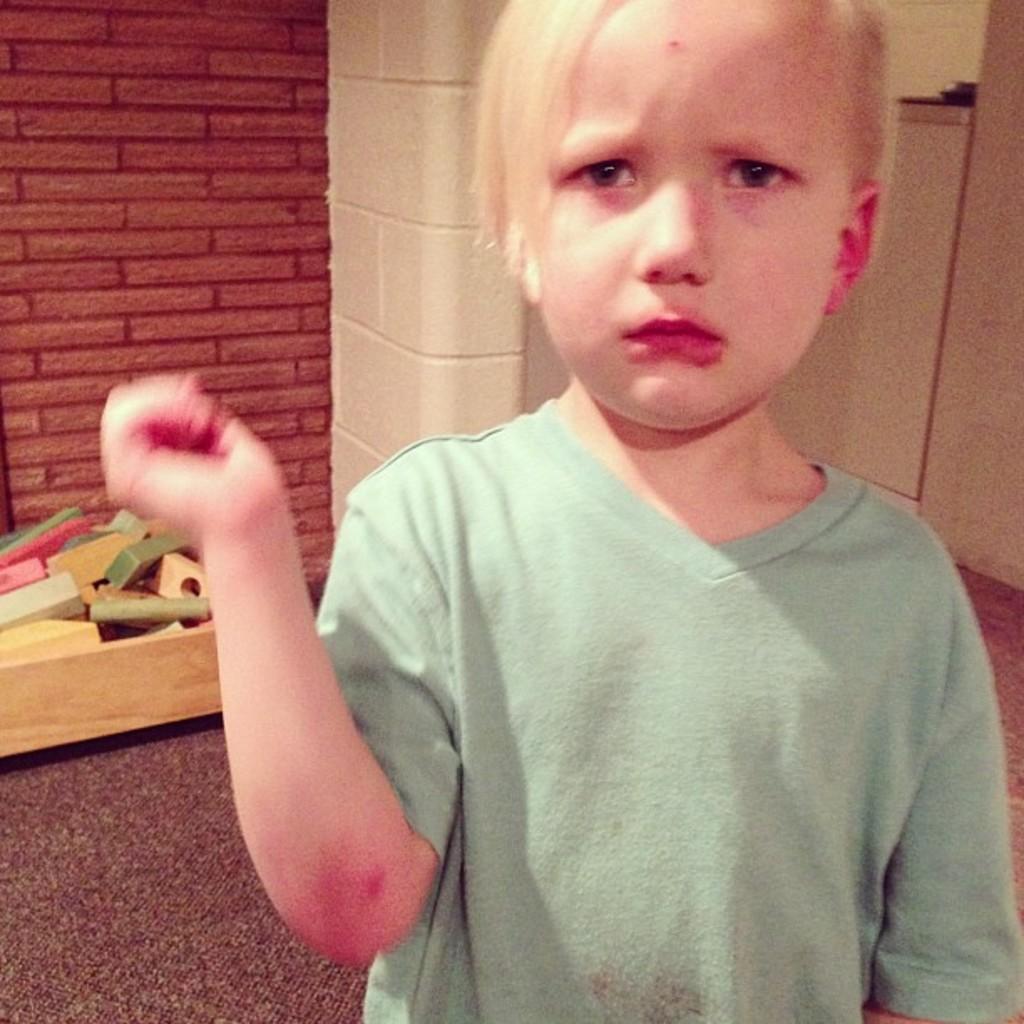Can you describe this image briefly? In this picture we can see a boy, he wore a green color T-shirt, behind to him we can see few things and red color wall. 